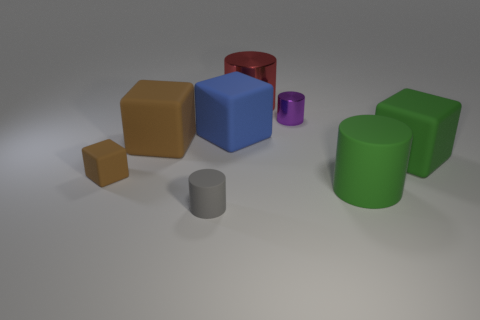Subtract all green blocks. How many blocks are left? 3 Subtract 1 cylinders. How many cylinders are left? 3 Subtract all red cubes. Subtract all brown cylinders. How many cubes are left? 4 Add 2 big blue cubes. How many objects exist? 10 Add 6 gray matte things. How many gray matte things exist? 7 Subtract 0 purple cubes. How many objects are left? 8 Subtract all tiny brown objects. Subtract all tiny things. How many objects are left? 4 Add 5 tiny purple things. How many tiny purple things are left? 6 